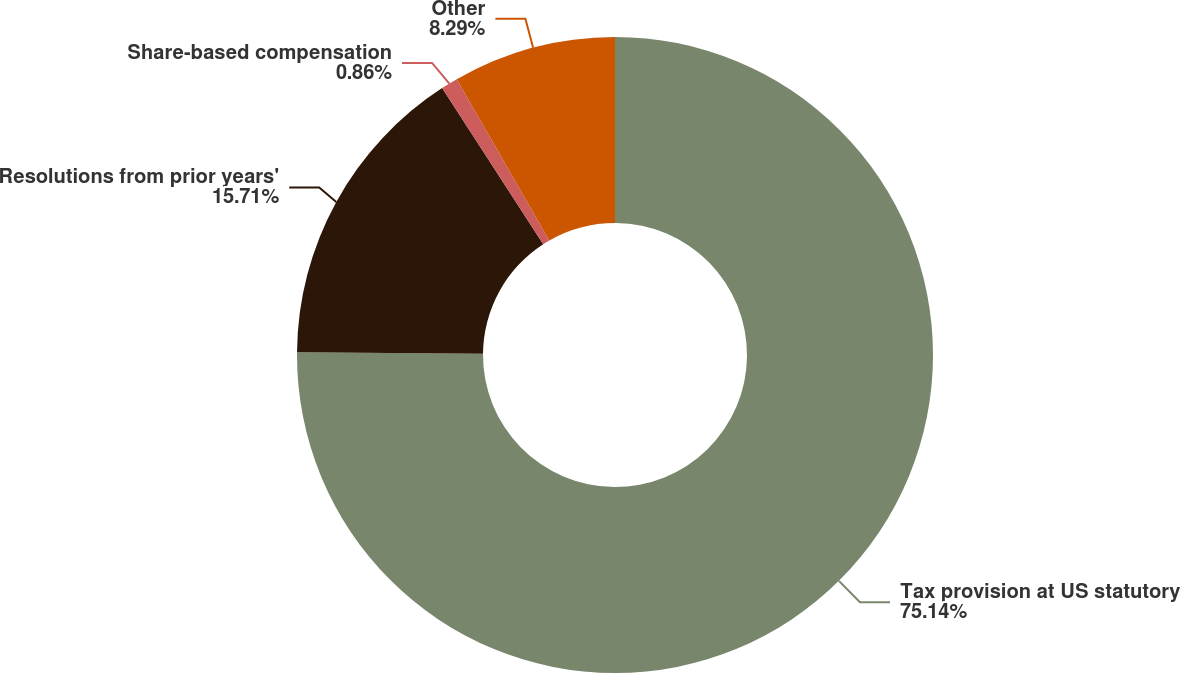Convert chart to OTSL. <chart><loc_0><loc_0><loc_500><loc_500><pie_chart><fcel>Tax provision at US statutory<fcel>Resolutions from prior years'<fcel>Share-based compensation<fcel>Other<nl><fcel>75.14%<fcel>15.71%<fcel>0.86%<fcel>8.29%<nl></chart> 